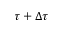<formula> <loc_0><loc_0><loc_500><loc_500>\tau + \Delta \tau</formula> 